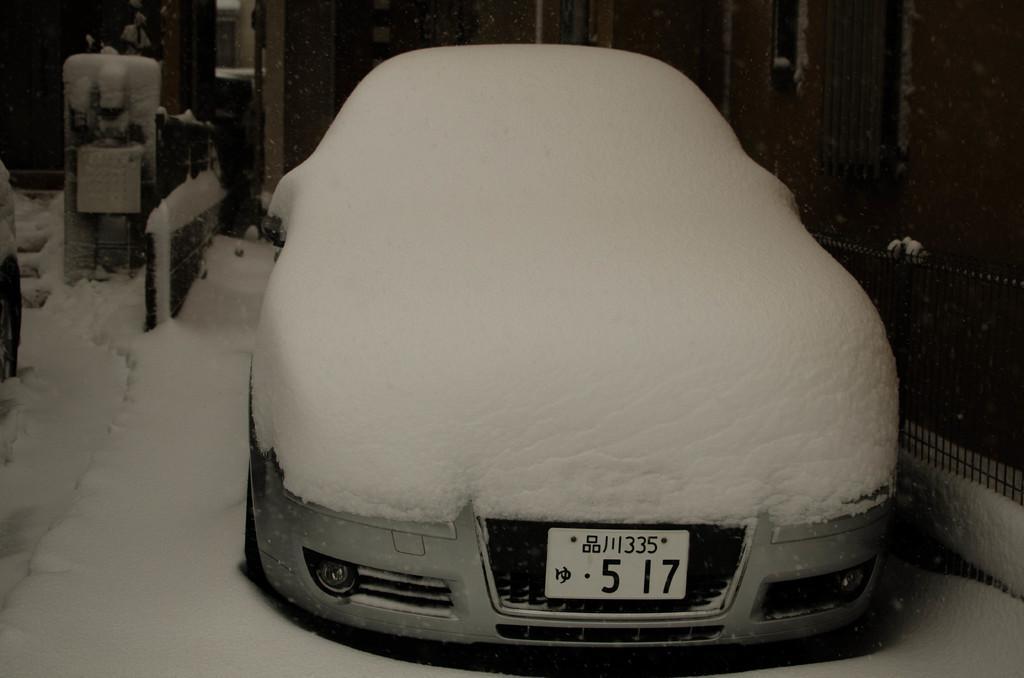Describe this image in one or two sentences. In this image we can see a car which is covered with the snow. We can also see the railing and also some other objects. At the bottom we can see the snow. 